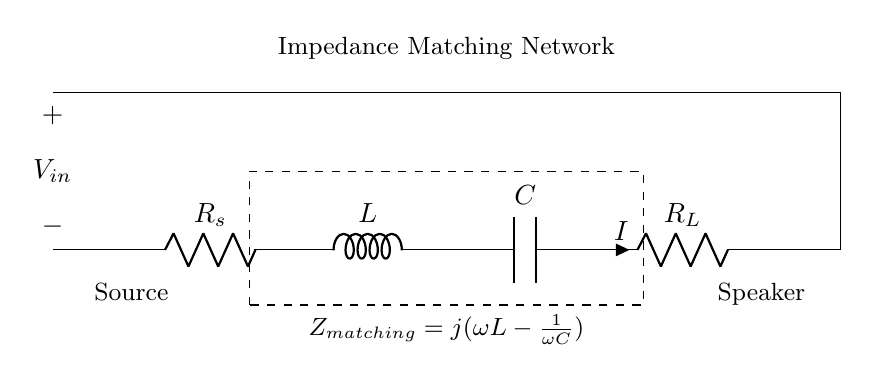What is the value of the source resistor? The value of the source resistor is indicated as R_s in the circuit diagram. Since specific values are not provided in the diagram, it is a placeholder for the resistance of the source.
Answer: R_s What is the current flowing through the load resistor? The current flowing through the load resistor, R_L, is represented by the symbol I in the diagram. It indicates the current at that point in the circuit.
Answer: I What type of circuit is shown? The circuit shown is an impedance matching network using resistors, capacitors, and inductors. This combination is specific to optimizing power transfer to speakers.
Answer: Impedance matching network What is the formula for the matching impedance? The formula given in the diagram for matching impedance is j(omega L - 1/(omega C). This expression combines the effects of the inductor and capacitor on the impedance seen from the load.
Answer: j(ωL - 1/(ωC)) What do the letters L and C stand for in the circuit? In the circuit, L stands for inductance (represented by the inductor) and C stands for capacitance (represented by the capacitor). These components are essential for tuning the impedance to match the load.
Answer: Inductor and Capacitor What is the purpose of impedance matching in this circuit? The purpose of impedance matching is to maximize power transfer from the source to the load (speakers in this case) by ensuring that the output impedance of the amplifier matches the load impedance.
Answer: Maximize power transfer 